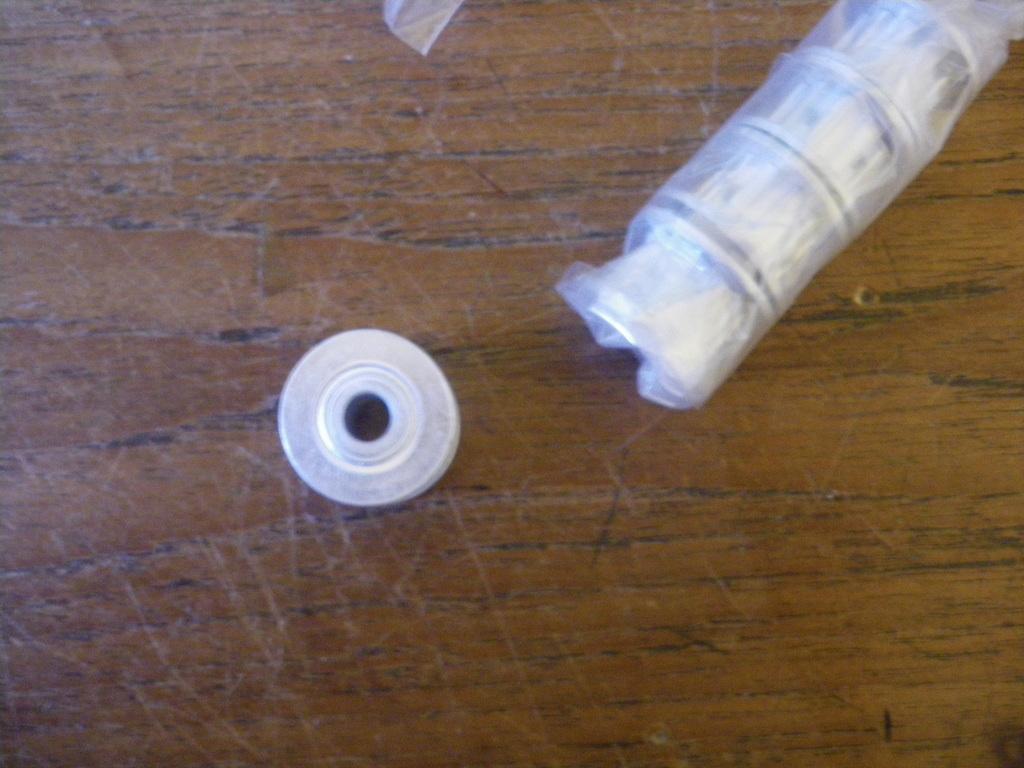Describe this image in one or two sentences. In this image there are two objects on the table. 